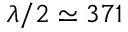Convert formula to latex. <formula><loc_0><loc_0><loc_500><loc_500>\lambda / 2 \simeq 3 7 1</formula> 